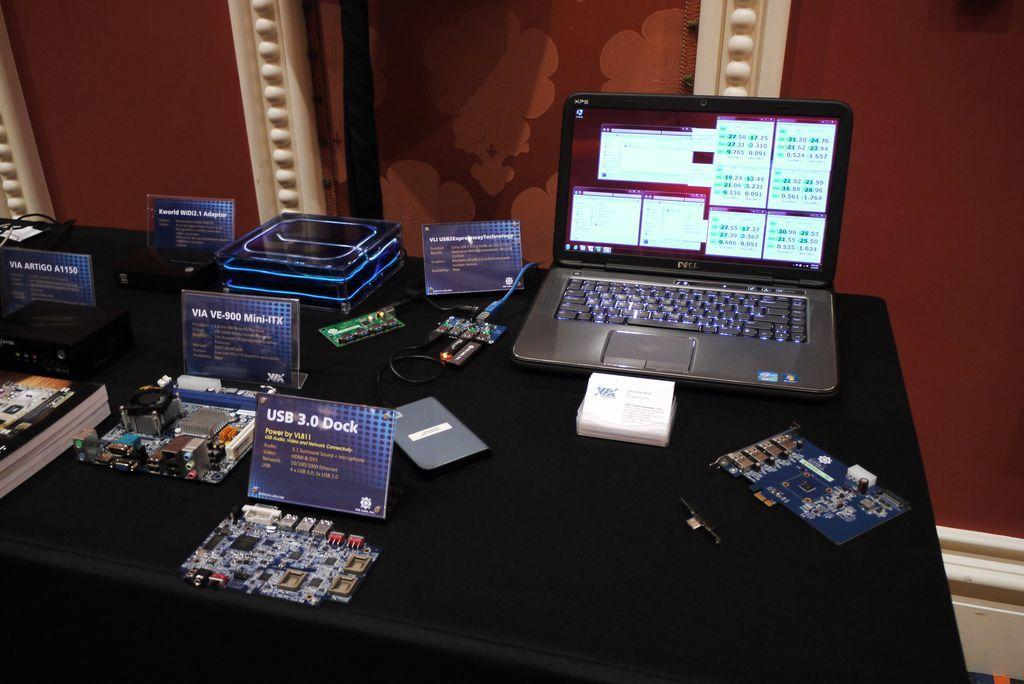<image>
Write a terse but informative summary of the picture. A table with a laptop and a display sign that reads USB 3.0 Dock. 